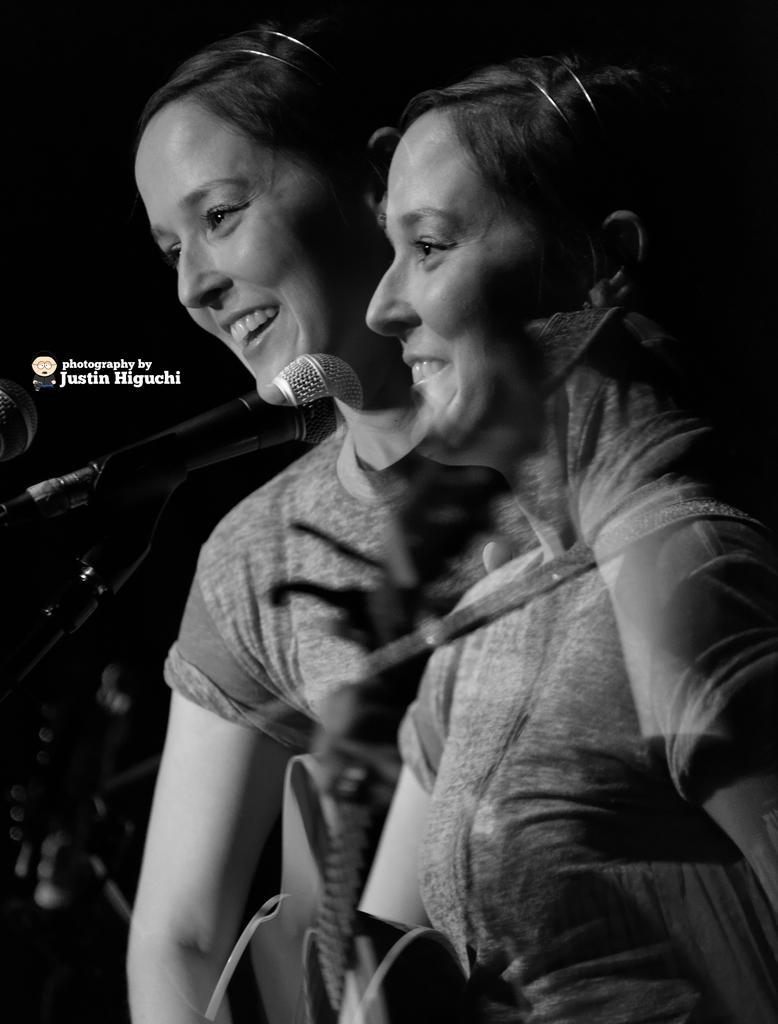Could you give a brief overview of what you see in this image? This is a black and white image. In this image we can see two ladies smiling. There are mics. In the background it is dark. Also something is written on the image. 